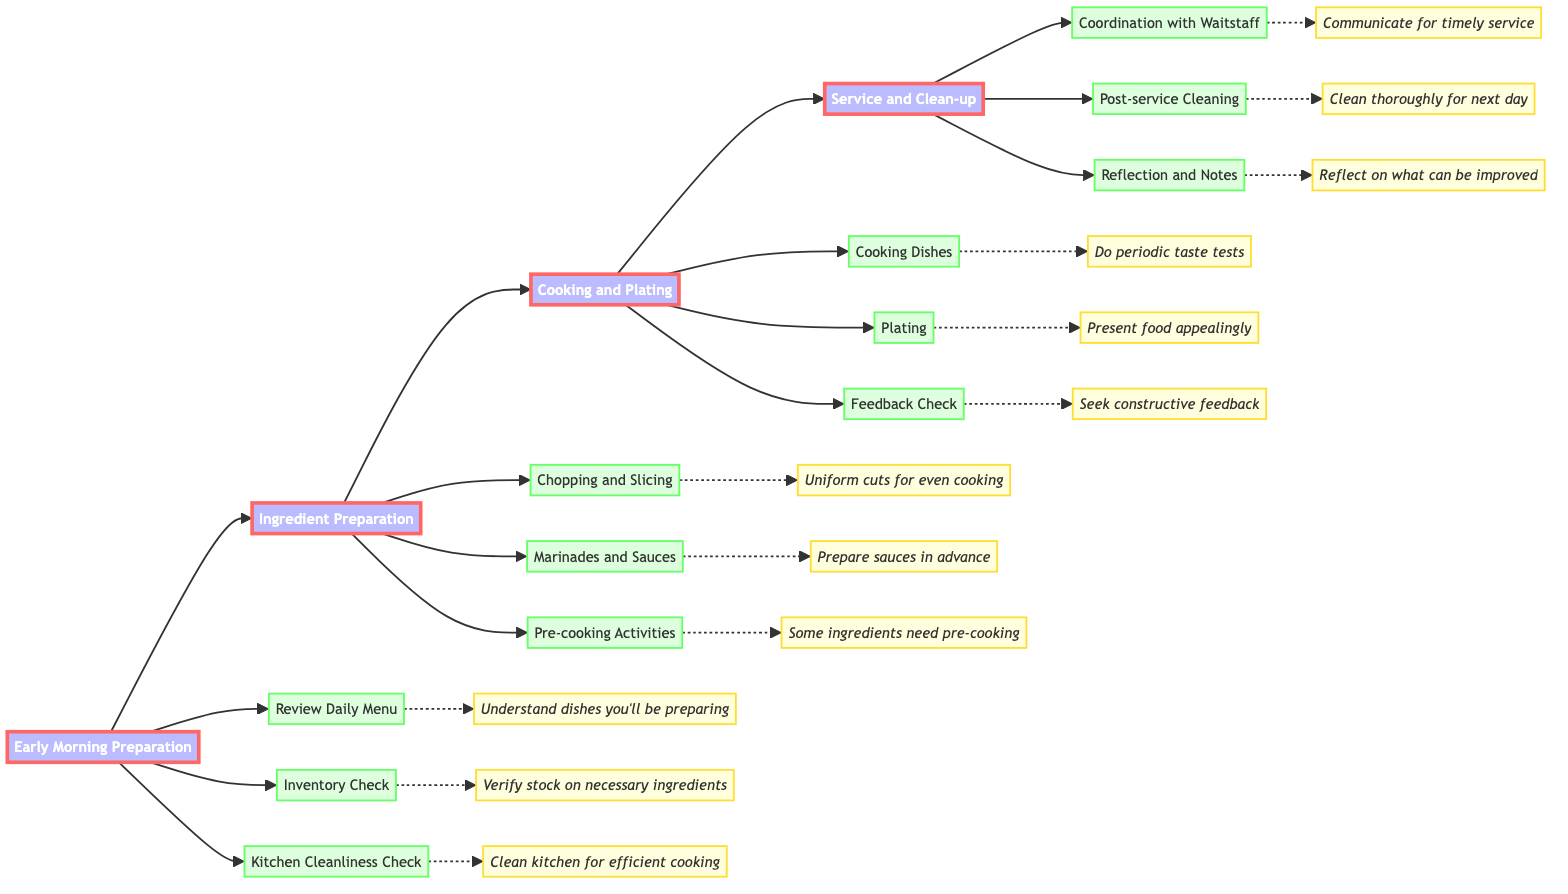What is the first step in the workflow? The first step in the workflow is labeled as "Early Morning Preparation," which initiates the daily kitchen operations. It's the topmost node of the flowchart.
Answer: Early Morning Preparation How many activities are in the "Cooking and Plating" step? In the "Cooking and Plating" step, there are three activities listed: "Cooking Dishes," "Plating," and "Feedback Check." Counting these activities provides the answer.
Answer: 3 What is the mentor's tip for "Chopping and Slicing"? Looking under the "Chopping and Slicing" task in the flowchart, the associated mentor tip is "Uniform cuts ensure even cooking and a better presentation." This is directly referenced under that task.
Answer: Uniform cuts ensure even cooking and a better presentation Which task follows "Ingredient Preparation" in the workflow? In the workflow, "Cooking and Plating" directly follows the "Ingredient Preparation" step, as illustrated by the arrow connection in the flowchart.
Answer: Cooking and Plating What is the relationship between "Post-service Cleaning" and "Reflection and Notes"? The "Post-service Cleaning" and "Reflection and Notes" tasks are both part of the "Service and Clean-up" step, indicating that they are sequential activities that occur within the same phase.
Answer: They are part of the same step What are the last two tasks in the workflow? The last two tasks in the workflow are "Post-service Cleaning" and "Reflection and Notes," which are at the end of the flowchart following the "Service and Clean-up" step, as indicated by their positioning and connections.
Answer: Post-service Cleaning, Reflection and Notes What does the mentor advise after "Cooking Dishes"? The mentor advises to "Seek constructive feedback" after the "Cooking Dishes" task, connecting this guidance directly to the subsequent task in the "Cooking and Plating" section.
Answer: Seek constructive feedback What is the tooltip for "Kitchen Cleanliness Check"? The tooltip under "Kitchen Cleanliness Check" indicates "A clean kitchen is the first step towards efficient and safe cooking," which is the customized advice attached to this task in the diagram.
Answer: A clean kitchen is the first step towards efficient and safe cooking 